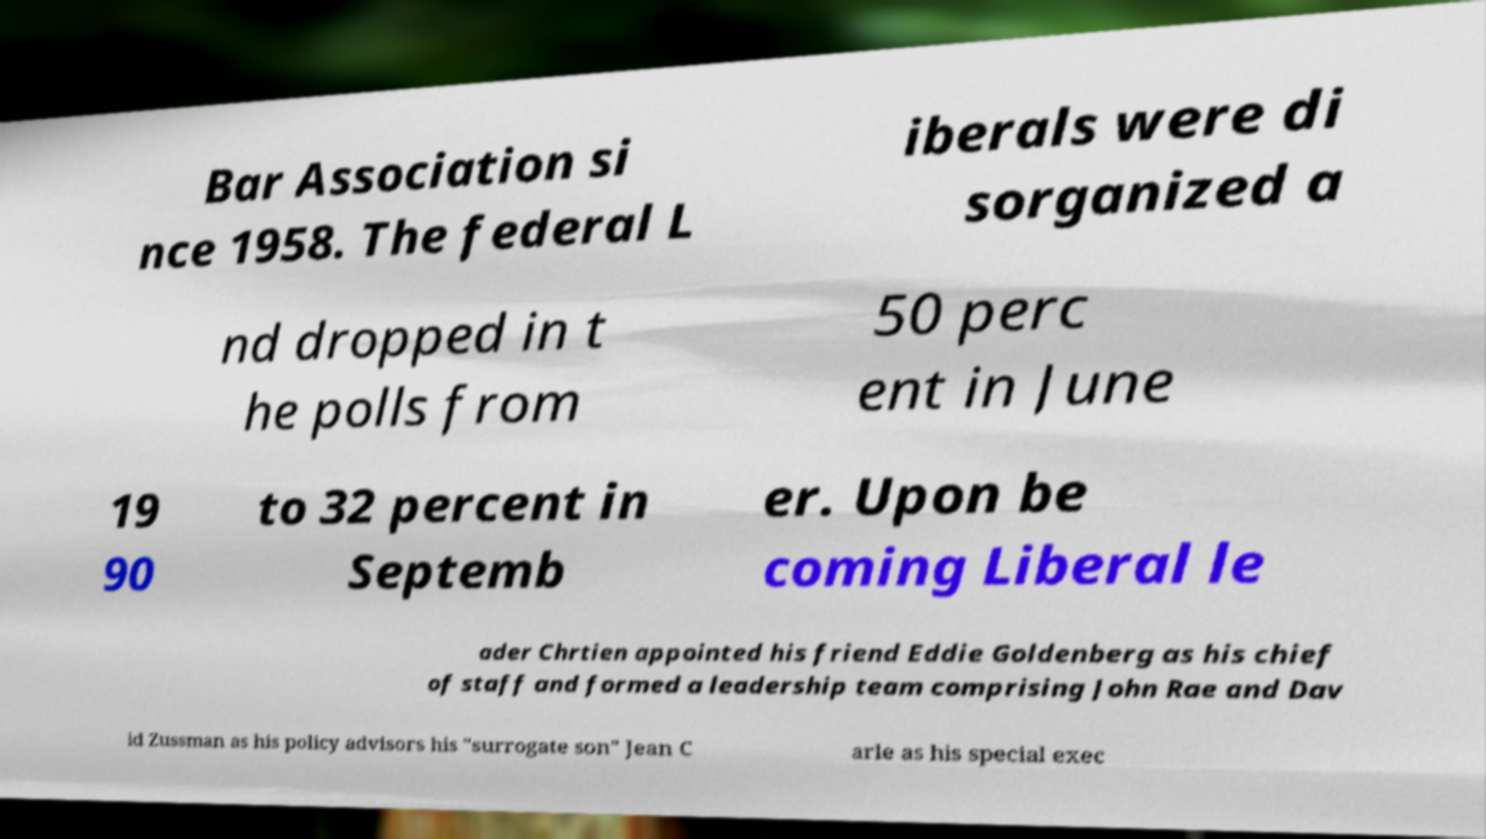Could you extract and type out the text from this image? Bar Association si nce 1958. The federal L iberals were di sorganized a nd dropped in t he polls from 50 perc ent in June 19 90 to 32 percent in Septemb er. Upon be coming Liberal le ader Chrtien appointed his friend Eddie Goldenberg as his chief of staff and formed a leadership team comprising John Rae and Dav id Zussman as his policy advisors his "surrogate son" Jean C arle as his special exec 